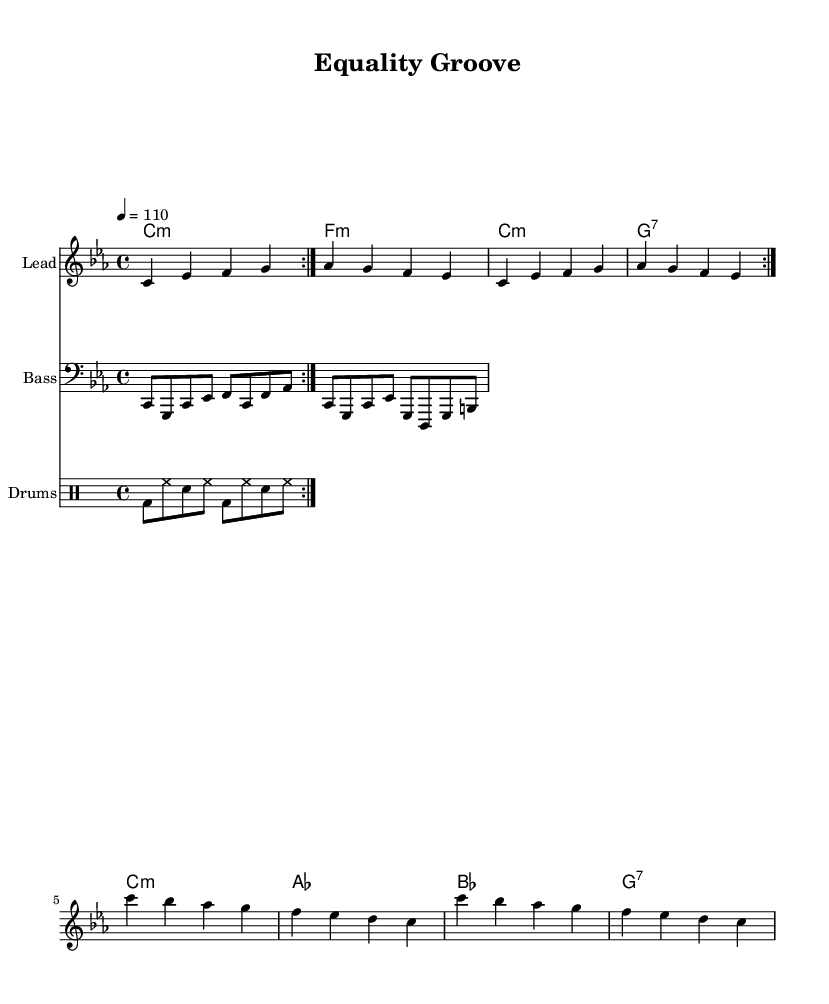What is the key signature of this music? The key signature is C minor, which has three flats (B♭, E♭, and A♭). This can be determined by looking at the key indicated at the beginning of the score.
Answer: C minor What is the time signature of this music? The time signature is 4/4, meaning there are four beats in each measure and the quarter note gets one beat. This is specified at the beginning of the score as part of the global notation.
Answer: 4/4 What is the tempo marking of this piece? The tempo marking indicates a tempo of 110 beats per minute, specified as "4 = 110" in the global section of the score. This tells musicians how fast to play the piece.
Answer: 110 How many measures are in the chorus? The chorus contains 4 measures based on the given lyrics and the corresponding melody, as observed from the structure indicated below the melody.
Answer: 4 What type of chord is used in the first measure? The first measure contains a C minor chord as indicated in the harmony section with a "c1:m" chord symbol. This specifies the chord type and root note played.
Answer: C minor What is the main theme of the lyrics in the verse? The main theme of the verse revolves around economic disparity, as reflected in the lyrics discussing "broken dreams" and the wealth of the rich. This thematic analysis can be derived from the content of the lyrics themselves.
Answer: Economic disparity How would you categorize the style of music represented here? The style of music represented here can be categorized as Rhythm and Blues, with elements of funk seen in the upbeat groove and socially conscious lyrics addressing economic issues. This can be concluded from the overall structure and thematic content of the song.
Answer: Rhythm and Blues 